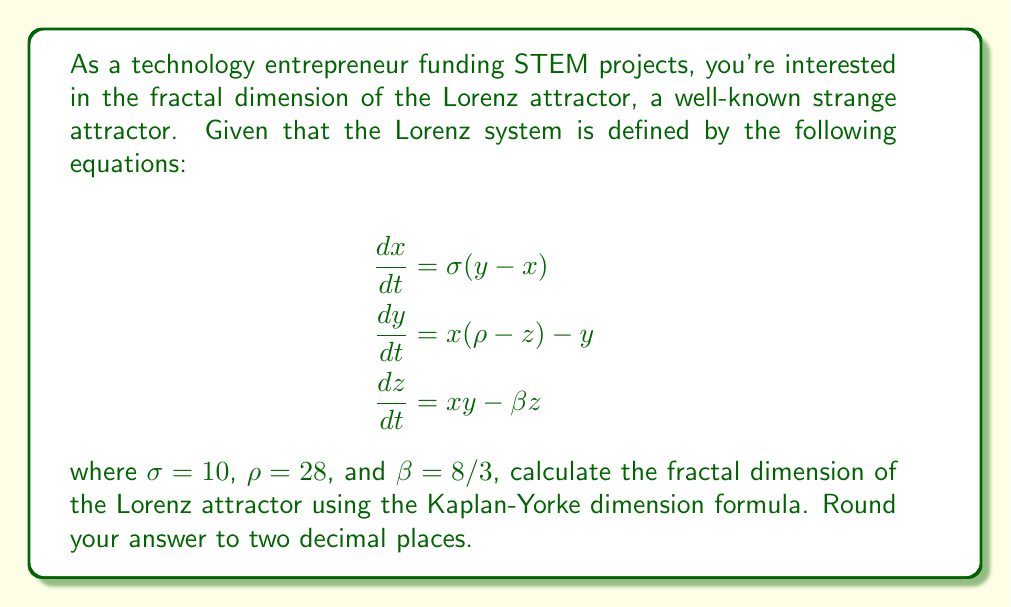Teach me how to tackle this problem. To calculate the fractal dimension of the Lorenz attractor, we'll use the Kaplan-Yorke dimension formula:

1) First, we need to calculate the Lyapunov exponents of the system. For the Lorenz attractor with the given parameters, the Lyapunov exponents are approximately:

   $\lambda_1 \approx 0.9056$
   $\lambda_2 \approx 0$
   $\lambda_3 \approx -14.5723$

2) The Kaplan-Yorke dimension is defined as:

   $$D_{KY} = j + \frac{\sum_{i=1}^j \lambda_i}{|\lambda_{j+1}|}$$

   where $j$ is the largest integer such that $\sum_{i=1}^j \lambda_i \geq 0$

3) In our case, $j = 2$ because:
   $\lambda_1 + \lambda_2 = 0.9056 + 0 = 0.9056 > 0$
   but $\lambda_1 + \lambda_2 + \lambda_3 = 0.9056 + 0 - 14.5723 < 0$

4) Now we can apply the formula:

   $$D_{KY} = 2 + \frac{\lambda_1 + \lambda_2}{|\lambda_3|}$$

5) Substituting the values:

   $$D_{KY} = 2 + \frac{0.9056 + 0}{|14.5723|} = 2 + \frac{0.9056}{14.5723}$$

6) Calculating:

   $$D_{KY} = 2 + 0.0621 = 2.0621$$

7) Rounding to two decimal places:

   $$D_{KY} \approx 2.06$$

This fractal dimension indicates that the Lorenz attractor is a fractal object with a dimension slightly higher than a 2D surface but less than a 3D volume.
Answer: 2.06 